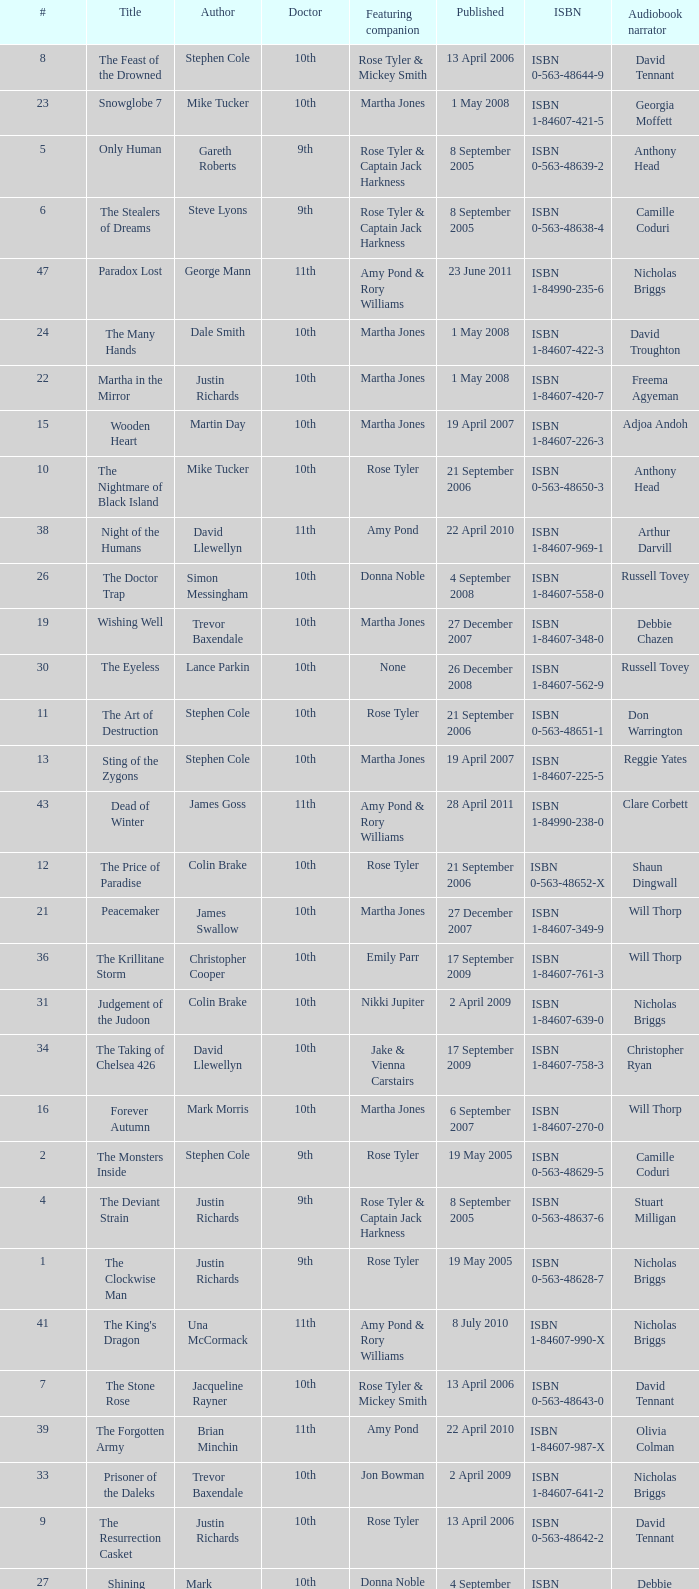What is the title of book number 7? The Stone Rose. 